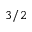Convert formula to latex. <formula><loc_0><loc_0><loc_500><loc_500>3 / 2</formula> 